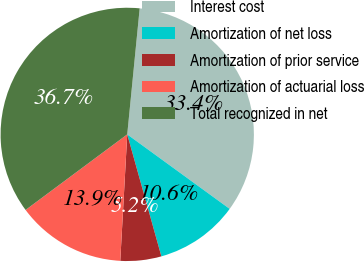Convert chart to OTSL. <chart><loc_0><loc_0><loc_500><loc_500><pie_chart><fcel>Interest cost<fcel>Amortization of net loss<fcel>Amortization of prior service<fcel>Amortization of actuarial loss<fcel>Total recognized in net<nl><fcel>33.44%<fcel>10.65%<fcel>5.22%<fcel>13.95%<fcel>36.74%<nl></chart> 